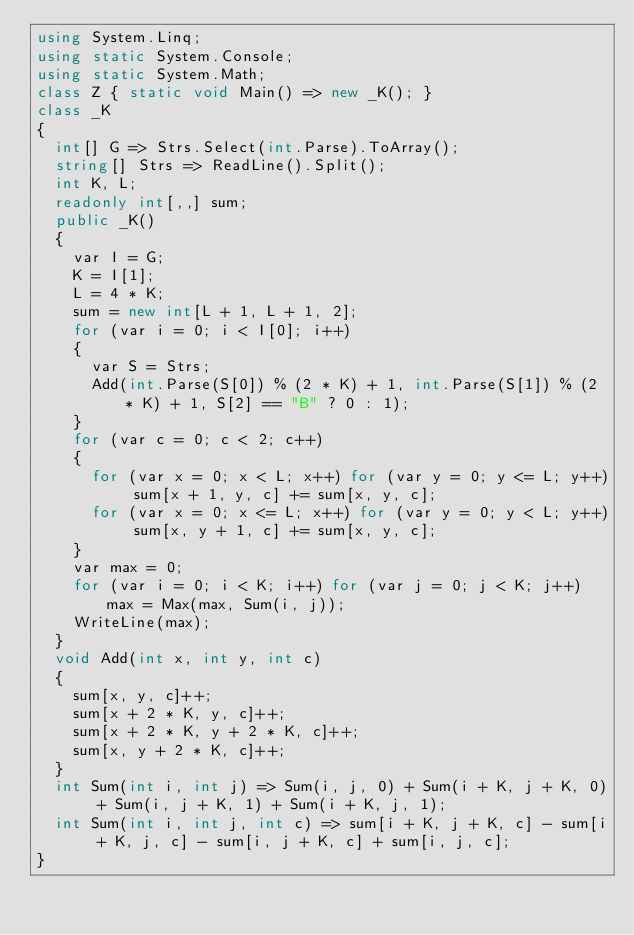Convert code to text. <code><loc_0><loc_0><loc_500><loc_500><_C#_>using System.Linq;
using static System.Console;
using static System.Math;
class Z { static void Main() => new _K(); }
class _K
{
	int[] G => Strs.Select(int.Parse).ToArray();
	string[] Strs => ReadLine().Split();
	int K, L;
	readonly int[,,] sum;
	public _K()
	{
		var I = G;
		K = I[1];
		L = 4 * K;
		sum = new int[L + 1, L + 1, 2];
		for (var i = 0; i < I[0]; i++)
		{
			var S = Strs;
			Add(int.Parse(S[0]) % (2 * K) + 1, int.Parse(S[1]) % (2 * K) + 1, S[2] == "B" ? 0 : 1);
		}
		for (var c = 0; c < 2; c++)
		{
			for (var x = 0; x < L; x++) for (var y = 0; y <= L; y++) sum[x + 1, y, c] += sum[x, y, c];
			for (var x = 0; x <= L; x++) for (var y = 0; y < L; y++) sum[x, y + 1, c] += sum[x, y, c];
		}
		var max = 0;
		for (var i = 0; i < K; i++) for (var j = 0; j < K; j++) max = Max(max, Sum(i, j));
		WriteLine(max);
	}
	void Add(int x, int y, int c)
	{
		sum[x, y, c]++;
		sum[x + 2 * K, y, c]++;
		sum[x + 2 * K, y + 2 * K, c]++;
		sum[x, y + 2 * K, c]++;
	}
	int Sum(int i, int j) => Sum(i, j, 0) + Sum(i + K, j + K, 0) + Sum(i, j + K, 1) + Sum(i + K, j, 1);
	int Sum(int i, int j, int c) => sum[i + K, j + K, c] - sum[i + K, j, c] - sum[i, j + K, c] + sum[i, j, c];
}
</code> 